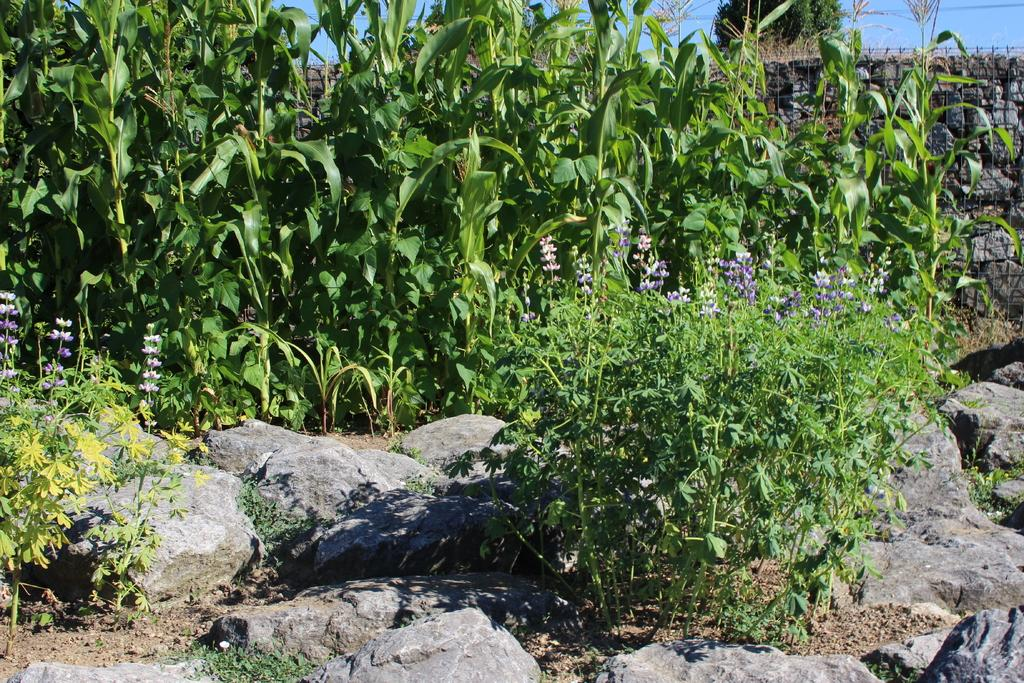What type of natural elements can be seen in the image? There are rocks and plants in the image. What material is present in the image? There is mesh in the image. What type of flora is visible in the image? There are flowers in the image. What type of muscle can be seen flexing in the image? There is no muscle present in the image; it features rocks, plants, mesh, and flowers. 